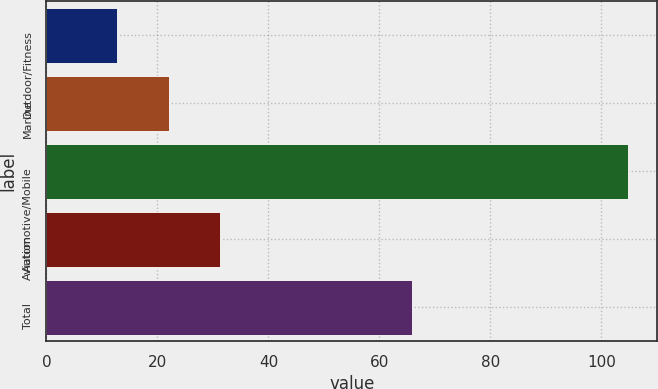<chart> <loc_0><loc_0><loc_500><loc_500><bar_chart><fcel>Outdoor/Fitness<fcel>Marine<fcel>Automotive/Mobile<fcel>Aviation<fcel>Total<nl><fcel>12.8<fcel>22<fcel>104.8<fcel>31.2<fcel>65.8<nl></chart> 